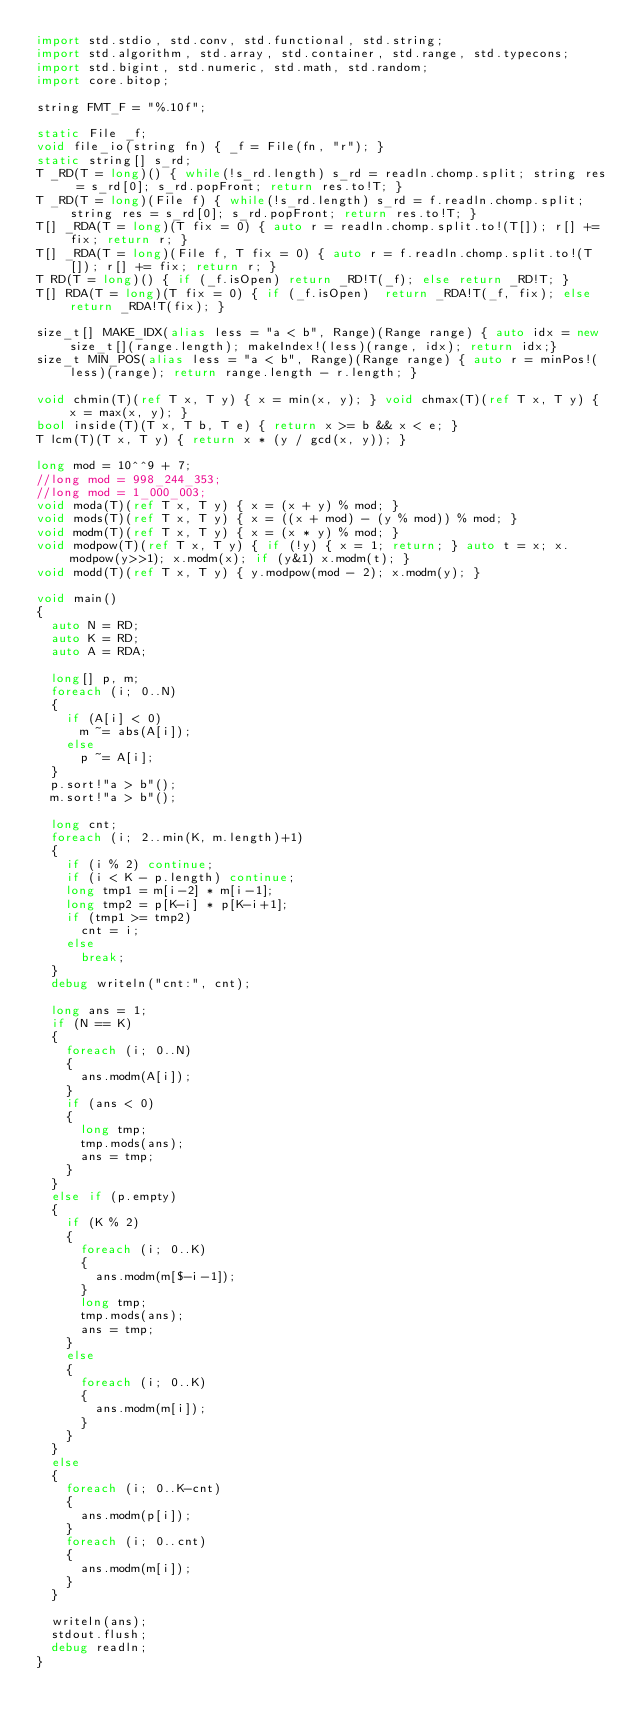Convert code to text. <code><loc_0><loc_0><loc_500><loc_500><_D_>import std.stdio, std.conv, std.functional, std.string;
import std.algorithm, std.array, std.container, std.range, std.typecons;
import std.bigint, std.numeric, std.math, std.random;
import core.bitop;

string FMT_F = "%.10f";

static File _f;
void file_io(string fn) { _f = File(fn, "r"); }
static string[] s_rd;
T _RD(T = long)() { while(!s_rd.length) s_rd = readln.chomp.split; string res = s_rd[0]; s_rd.popFront; return res.to!T; }
T _RD(T = long)(File f) { while(!s_rd.length) s_rd = f.readln.chomp.split; string res = s_rd[0]; s_rd.popFront; return res.to!T; }
T[] _RDA(T = long)(T fix = 0) { auto r = readln.chomp.split.to!(T[]); r[] += fix; return r; }
T[] _RDA(T = long)(File f, T fix = 0) { auto r = f.readln.chomp.split.to!(T[]); r[] += fix; return r; }
T RD(T = long)() { if (_f.isOpen) return _RD!T(_f); else return _RD!T; }
T[] RDA(T = long)(T fix = 0) { if (_f.isOpen)  return _RDA!T(_f, fix); else return _RDA!T(fix); }

size_t[] MAKE_IDX(alias less = "a < b", Range)(Range range) { auto idx = new size_t[](range.length); makeIndex!(less)(range, idx); return idx;}
size_t MIN_POS(alias less = "a < b", Range)(Range range) { auto r = minPos!(less)(range); return range.length - r.length; }

void chmin(T)(ref T x, T y) { x = min(x, y); } void chmax(T)(ref T x, T y) { x = max(x, y); }
bool inside(T)(T x, T b, T e) { return x >= b && x < e; }
T lcm(T)(T x, T y) { return x * (y / gcd(x, y)); }

long mod = 10^^9 + 7;
//long mod = 998_244_353;
//long mod = 1_000_003;
void moda(T)(ref T x, T y) { x = (x + y) % mod; }
void mods(T)(ref T x, T y) { x = ((x + mod) - (y % mod)) % mod; }
void modm(T)(ref T x, T y) { x = (x * y) % mod; }
void modpow(T)(ref T x, T y) { if (!y) { x = 1; return; } auto t = x; x.modpow(y>>1); x.modm(x); if (y&1) x.modm(t); }
void modd(T)(ref T x, T y) { y.modpow(mod - 2); x.modm(y); }

void main()
{
	auto N = RD;
	auto K = RD;
	auto A = RDA;

	long[] p, m;
	foreach (i; 0..N)
	{
		if (A[i] < 0)
			m ~= abs(A[i]);
		else
			p ~= A[i];
	}
	p.sort!"a > b"();
	m.sort!"a > b"();

	long cnt;
	foreach (i; 2..min(K, m.length)+1)
	{
		if (i % 2) continue;
		if (i < K - p.length) continue;
		long tmp1 = m[i-2] * m[i-1];
		long tmp2 = p[K-i] * p[K-i+1];
		if (tmp1 >= tmp2)
			cnt = i;
		else
			break;
	}
	debug writeln("cnt:", cnt);

	long ans = 1;
	if (N == K)
	{
		foreach (i; 0..N)
		{
			ans.modm(A[i]);
		}
		if (ans < 0)
		{
			long tmp;
			tmp.mods(ans);
			ans = tmp;
		}
	}
	else if (p.empty)
	{
		if (K % 2)
		{
			foreach (i; 0..K)
			{
				ans.modm(m[$-i-1]);
			}
			long tmp;
			tmp.mods(ans);
			ans = tmp;
		}
		else
		{
			foreach (i; 0..K)
			{
				ans.modm(m[i]);
			}
		}
	}
	else
	{
		foreach (i; 0..K-cnt)
		{
			ans.modm(p[i]);
		}
		foreach (i; 0..cnt)
		{
			ans.modm(m[i]);
		}
	}

	writeln(ans);
	stdout.flush;
	debug readln;
}</code> 